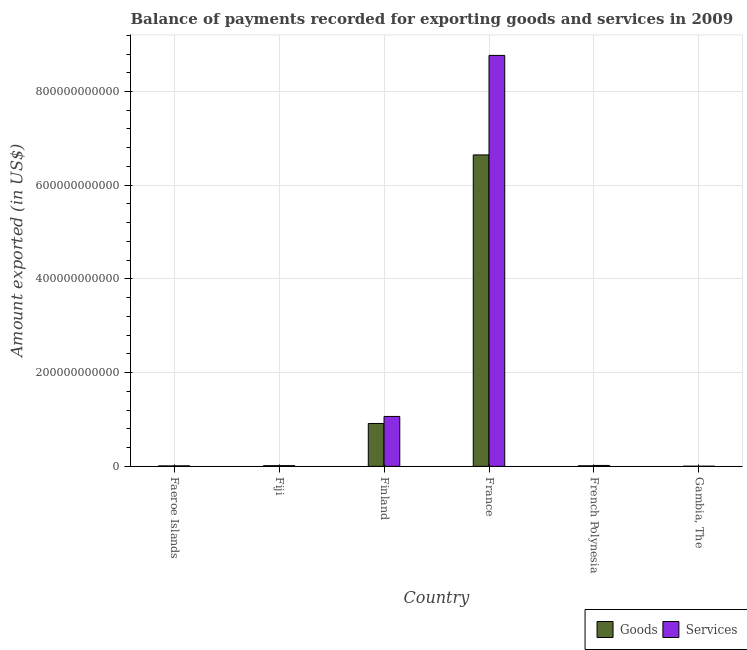How many groups of bars are there?
Your answer should be compact. 6. Are the number of bars per tick equal to the number of legend labels?
Ensure brevity in your answer.  Yes. How many bars are there on the 5th tick from the left?
Offer a terse response. 2. How many bars are there on the 4th tick from the right?
Ensure brevity in your answer.  2. What is the label of the 1st group of bars from the left?
Make the answer very short. Faeroe Islands. What is the amount of services exported in Fiji?
Your answer should be compact. 1.48e+09. Across all countries, what is the maximum amount of services exported?
Give a very brief answer. 8.77e+11. Across all countries, what is the minimum amount of services exported?
Ensure brevity in your answer.  2.90e+08. In which country was the amount of goods exported maximum?
Your answer should be compact. France. In which country was the amount of services exported minimum?
Keep it short and to the point. Gambia, The. What is the total amount of goods exported in the graph?
Ensure brevity in your answer.  7.60e+11. What is the difference between the amount of goods exported in Faeroe Islands and that in Finland?
Ensure brevity in your answer.  -9.05e+1. What is the difference between the amount of goods exported in French Polynesia and the amount of services exported in France?
Ensure brevity in your answer.  -8.76e+11. What is the average amount of goods exported per country?
Give a very brief answer. 1.27e+11. What is the difference between the amount of goods exported and amount of services exported in Fiji?
Provide a succinct answer. -6.12e+07. What is the ratio of the amount of services exported in Fiji to that in Finland?
Offer a terse response. 0.01. What is the difference between the highest and the second highest amount of goods exported?
Your response must be concise. 5.73e+11. What is the difference between the highest and the lowest amount of goods exported?
Your answer should be compact. 6.64e+11. Is the sum of the amount of goods exported in Faeroe Islands and French Polynesia greater than the maximum amount of services exported across all countries?
Offer a very short reply. No. What does the 1st bar from the left in Finland represents?
Your response must be concise. Goods. What does the 1st bar from the right in Gambia, The represents?
Your response must be concise. Services. Are all the bars in the graph horizontal?
Provide a short and direct response. No. How many countries are there in the graph?
Your answer should be compact. 6. What is the difference between two consecutive major ticks on the Y-axis?
Your answer should be compact. 2.00e+11. Are the values on the major ticks of Y-axis written in scientific E-notation?
Provide a succinct answer. No. Does the graph contain grids?
Give a very brief answer. Yes. What is the title of the graph?
Your response must be concise. Balance of payments recorded for exporting goods and services in 2009. What is the label or title of the X-axis?
Keep it short and to the point. Country. What is the label or title of the Y-axis?
Your response must be concise. Amount exported (in US$). What is the Amount exported (in US$) in Goods in Faeroe Islands?
Ensure brevity in your answer.  9.36e+08. What is the Amount exported (in US$) of Services in Faeroe Islands?
Your response must be concise. 1.09e+09. What is the Amount exported (in US$) in Goods in Fiji?
Give a very brief answer. 1.42e+09. What is the Amount exported (in US$) in Services in Fiji?
Give a very brief answer. 1.48e+09. What is the Amount exported (in US$) in Goods in Finland?
Your answer should be compact. 9.15e+1. What is the Amount exported (in US$) in Services in Finland?
Offer a terse response. 1.07e+11. What is the Amount exported (in US$) of Goods in France?
Your response must be concise. 6.65e+11. What is the Amount exported (in US$) in Services in France?
Your answer should be very brief. 8.77e+11. What is the Amount exported (in US$) in Goods in French Polynesia?
Offer a terse response. 1.16e+09. What is the Amount exported (in US$) in Services in French Polynesia?
Provide a succinct answer. 1.94e+09. What is the Amount exported (in US$) of Goods in Gambia, The?
Your answer should be very brief. 2.78e+08. What is the Amount exported (in US$) in Services in Gambia, The?
Offer a very short reply. 2.90e+08. Across all countries, what is the maximum Amount exported (in US$) in Goods?
Your answer should be very brief. 6.65e+11. Across all countries, what is the maximum Amount exported (in US$) in Services?
Provide a short and direct response. 8.77e+11. Across all countries, what is the minimum Amount exported (in US$) in Goods?
Offer a terse response. 2.78e+08. Across all countries, what is the minimum Amount exported (in US$) in Services?
Give a very brief answer. 2.90e+08. What is the total Amount exported (in US$) of Goods in the graph?
Your answer should be compact. 7.60e+11. What is the total Amount exported (in US$) of Services in the graph?
Offer a very short reply. 9.88e+11. What is the difference between the Amount exported (in US$) in Goods in Faeroe Islands and that in Fiji?
Offer a very short reply. -4.86e+08. What is the difference between the Amount exported (in US$) of Services in Faeroe Islands and that in Fiji?
Make the answer very short. -3.88e+08. What is the difference between the Amount exported (in US$) in Goods in Faeroe Islands and that in Finland?
Provide a short and direct response. -9.05e+1. What is the difference between the Amount exported (in US$) in Services in Faeroe Islands and that in Finland?
Give a very brief answer. -1.05e+11. What is the difference between the Amount exported (in US$) of Goods in Faeroe Islands and that in France?
Make the answer very short. -6.64e+11. What is the difference between the Amount exported (in US$) in Services in Faeroe Islands and that in France?
Provide a succinct answer. -8.76e+11. What is the difference between the Amount exported (in US$) in Goods in Faeroe Islands and that in French Polynesia?
Offer a terse response. -2.25e+08. What is the difference between the Amount exported (in US$) in Services in Faeroe Islands and that in French Polynesia?
Give a very brief answer. -8.40e+08. What is the difference between the Amount exported (in US$) in Goods in Faeroe Islands and that in Gambia, The?
Give a very brief answer. 6.57e+08. What is the difference between the Amount exported (in US$) of Services in Faeroe Islands and that in Gambia, The?
Give a very brief answer. 8.05e+08. What is the difference between the Amount exported (in US$) of Goods in Fiji and that in Finland?
Your response must be concise. -9.01e+1. What is the difference between the Amount exported (in US$) of Services in Fiji and that in Finland?
Provide a short and direct response. -1.05e+11. What is the difference between the Amount exported (in US$) of Goods in Fiji and that in France?
Provide a succinct answer. -6.63e+11. What is the difference between the Amount exported (in US$) in Services in Fiji and that in France?
Offer a terse response. -8.76e+11. What is the difference between the Amount exported (in US$) of Goods in Fiji and that in French Polynesia?
Keep it short and to the point. 2.61e+08. What is the difference between the Amount exported (in US$) in Services in Fiji and that in French Polynesia?
Your response must be concise. -4.52e+08. What is the difference between the Amount exported (in US$) in Goods in Fiji and that in Gambia, The?
Provide a succinct answer. 1.14e+09. What is the difference between the Amount exported (in US$) of Services in Fiji and that in Gambia, The?
Provide a succinct answer. 1.19e+09. What is the difference between the Amount exported (in US$) of Goods in Finland and that in France?
Give a very brief answer. -5.73e+11. What is the difference between the Amount exported (in US$) of Services in Finland and that in France?
Your answer should be compact. -7.70e+11. What is the difference between the Amount exported (in US$) of Goods in Finland and that in French Polynesia?
Your answer should be very brief. 9.03e+1. What is the difference between the Amount exported (in US$) in Services in Finland and that in French Polynesia?
Offer a very short reply. 1.05e+11. What is the difference between the Amount exported (in US$) of Goods in Finland and that in Gambia, The?
Your answer should be compact. 9.12e+1. What is the difference between the Amount exported (in US$) in Services in Finland and that in Gambia, The?
Provide a short and direct response. 1.06e+11. What is the difference between the Amount exported (in US$) of Goods in France and that in French Polynesia?
Your answer should be compact. 6.63e+11. What is the difference between the Amount exported (in US$) of Services in France and that in French Polynesia?
Offer a terse response. 8.75e+11. What is the difference between the Amount exported (in US$) of Goods in France and that in Gambia, The?
Provide a succinct answer. 6.64e+11. What is the difference between the Amount exported (in US$) in Services in France and that in Gambia, The?
Give a very brief answer. 8.77e+11. What is the difference between the Amount exported (in US$) in Goods in French Polynesia and that in Gambia, The?
Offer a terse response. 8.82e+08. What is the difference between the Amount exported (in US$) of Services in French Polynesia and that in Gambia, The?
Offer a terse response. 1.65e+09. What is the difference between the Amount exported (in US$) of Goods in Faeroe Islands and the Amount exported (in US$) of Services in Fiji?
Your response must be concise. -5.47e+08. What is the difference between the Amount exported (in US$) in Goods in Faeroe Islands and the Amount exported (in US$) in Services in Finland?
Your response must be concise. -1.06e+11. What is the difference between the Amount exported (in US$) in Goods in Faeroe Islands and the Amount exported (in US$) in Services in France?
Make the answer very short. -8.76e+11. What is the difference between the Amount exported (in US$) of Goods in Faeroe Islands and the Amount exported (in US$) of Services in French Polynesia?
Make the answer very short. -1.00e+09. What is the difference between the Amount exported (in US$) in Goods in Faeroe Islands and the Amount exported (in US$) in Services in Gambia, The?
Provide a succinct answer. 6.46e+08. What is the difference between the Amount exported (in US$) of Goods in Fiji and the Amount exported (in US$) of Services in Finland?
Provide a succinct answer. -1.05e+11. What is the difference between the Amount exported (in US$) in Goods in Fiji and the Amount exported (in US$) in Services in France?
Provide a short and direct response. -8.76e+11. What is the difference between the Amount exported (in US$) of Goods in Fiji and the Amount exported (in US$) of Services in French Polynesia?
Provide a succinct answer. -5.14e+08. What is the difference between the Amount exported (in US$) in Goods in Fiji and the Amount exported (in US$) in Services in Gambia, The?
Provide a short and direct response. 1.13e+09. What is the difference between the Amount exported (in US$) in Goods in Finland and the Amount exported (in US$) in Services in France?
Provide a short and direct response. -7.85e+11. What is the difference between the Amount exported (in US$) in Goods in Finland and the Amount exported (in US$) in Services in French Polynesia?
Provide a short and direct response. 8.95e+1. What is the difference between the Amount exported (in US$) in Goods in Finland and the Amount exported (in US$) in Services in Gambia, The?
Keep it short and to the point. 9.12e+1. What is the difference between the Amount exported (in US$) in Goods in France and the Amount exported (in US$) in Services in French Polynesia?
Your answer should be compact. 6.63e+11. What is the difference between the Amount exported (in US$) in Goods in France and the Amount exported (in US$) in Services in Gambia, The?
Provide a succinct answer. 6.64e+11. What is the difference between the Amount exported (in US$) of Goods in French Polynesia and the Amount exported (in US$) of Services in Gambia, The?
Your answer should be very brief. 8.71e+08. What is the average Amount exported (in US$) in Goods per country?
Provide a short and direct response. 1.27e+11. What is the average Amount exported (in US$) in Services per country?
Provide a short and direct response. 1.65e+11. What is the difference between the Amount exported (in US$) of Goods and Amount exported (in US$) of Services in Faeroe Islands?
Keep it short and to the point. -1.59e+08. What is the difference between the Amount exported (in US$) of Goods and Amount exported (in US$) of Services in Fiji?
Provide a short and direct response. -6.12e+07. What is the difference between the Amount exported (in US$) of Goods and Amount exported (in US$) of Services in Finland?
Your response must be concise. -1.50e+1. What is the difference between the Amount exported (in US$) in Goods and Amount exported (in US$) in Services in France?
Give a very brief answer. -2.12e+11. What is the difference between the Amount exported (in US$) in Goods and Amount exported (in US$) in Services in French Polynesia?
Give a very brief answer. -7.74e+08. What is the difference between the Amount exported (in US$) of Goods and Amount exported (in US$) of Services in Gambia, The?
Keep it short and to the point. -1.17e+07. What is the ratio of the Amount exported (in US$) in Goods in Faeroe Islands to that in Fiji?
Your response must be concise. 0.66. What is the ratio of the Amount exported (in US$) of Services in Faeroe Islands to that in Fiji?
Offer a terse response. 0.74. What is the ratio of the Amount exported (in US$) of Goods in Faeroe Islands to that in Finland?
Make the answer very short. 0.01. What is the ratio of the Amount exported (in US$) of Services in Faeroe Islands to that in Finland?
Your response must be concise. 0.01. What is the ratio of the Amount exported (in US$) in Goods in Faeroe Islands to that in France?
Provide a short and direct response. 0. What is the ratio of the Amount exported (in US$) of Services in Faeroe Islands to that in France?
Your response must be concise. 0. What is the ratio of the Amount exported (in US$) of Goods in Faeroe Islands to that in French Polynesia?
Provide a succinct answer. 0.81. What is the ratio of the Amount exported (in US$) of Services in Faeroe Islands to that in French Polynesia?
Provide a succinct answer. 0.57. What is the ratio of the Amount exported (in US$) in Goods in Faeroe Islands to that in Gambia, The?
Offer a terse response. 3.36. What is the ratio of the Amount exported (in US$) of Services in Faeroe Islands to that in Gambia, The?
Provide a succinct answer. 3.77. What is the ratio of the Amount exported (in US$) in Goods in Fiji to that in Finland?
Keep it short and to the point. 0.02. What is the ratio of the Amount exported (in US$) of Services in Fiji to that in Finland?
Offer a terse response. 0.01. What is the ratio of the Amount exported (in US$) in Goods in Fiji to that in France?
Provide a short and direct response. 0. What is the ratio of the Amount exported (in US$) in Services in Fiji to that in France?
Offer a very short reply. 0. What is the ratio of the Amount exported (in US$) of Goods in Fiji to that in French Polynesia?
Ensure brevity in your answer.  1.22. What is the ratio of the Amount exported (in US$) in Services in Fiji to that in French Polynesia?
Offer a terse response. 0.77. What is the ratio of the Amount exported (in US$) in Goods in Fiji to that in Gambia, The?
Make the answer very short. 5.11. What is the ratio of the Amount exported (in US$) in Services in Fiji to that in Gambia, The?
Your response must be concise. 5.11. What is the ratio of the Amount exported (in US$) in Goods in Finland to that in France?
Give a very brief answer. 0.14. What is the ratio of the Amount exported (in US$) of Services in Finland to that in France?
Your answer should be compact. 0.12. What is the ratio of the Amount exported (in US$) in Goods in Finland to that in French Polynesia?
Make the answer very short. 78.82. What is the ratio of the Amount exported (in US$) in Services in Finland to that in French Polynesia?
Provide a short and direct response. 55.04. What is the ratio of the Amount exported (in US$) of Goods in Finland to that in Gambia, The?
Give a very brief answer. 328.61. What is the ratio of the Amount exported (in US$) of Services in Finland to that in Gambia, The?
Offer a terse response. 367.15. What is the ratio of the Amount exported (in US$) in Goods in France to that in French Polynesia?
Your answer should be compact. 572.61. What is the ratio of the Amount exported (in US$) in Services in France to that in French Polynesia?
Ensure brevity in your answer.  453.18. What is the ratio of the Amount exported (in US$) of Goods in France to that in Gambia, The?
Your answer should be very brief. 2387.34. What is the ratio of the Amount exported (in US$) in Services in France to that in Gambia, The?
Offer a very short reply. 3023.2. What is the ratio of the Amount exported (in US$) in Goods in French Polynesia to that in Gambia, The?
Offer a terse response. 4.17. What is the ratio of the Amount exported (in US$) of Services in French Polynesia to that in Gambia, The?
Ensure brevity in your answer.  6.67. What is the difference between the highest and the second highest Amount exported (in US$) of Goods?
Your answer should be compact. 5.73e+11. What is the difference between the highest and the second highest Amount exported (in US$) in Services?
Keep it short and to the point. 7.70e+11. What is the difference between the highest and the lowest Amount exported (in US$) of Goods?
Provide a short and direct response. 6.64e+11. What is the difference between the highest and the lowest Amount exported (in US$) of Services?
Offer a terse response. 8.77e+11. 